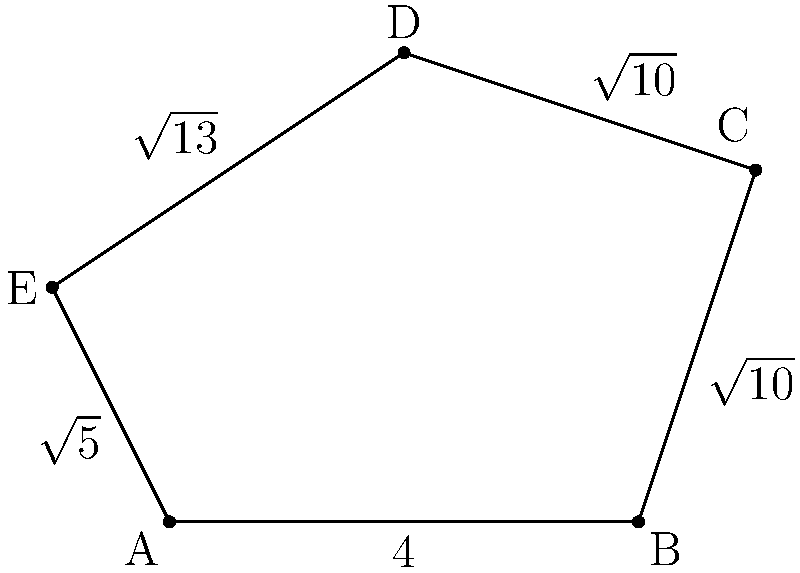As a future diplomatic translator, you might encounter geometrical descriptions in various documents. Consider the irregular pentagon ABCDE shown in the figure. Given that the coordinates of the vertices are A(0,0), B(4,0), C(5,3), D(2,4), and E(-1,2), calculate the perimeter of the pentagon. Express your answer in simplified radical form. To find the perimeter of the irregular pentagon, we need to calculate the distance between each pair of consecutive vertices and sum them up. We'll use the distance formula: $d = \sqrt{(x_2-x_1)^2 + (y_2-y_1)^2}$

1. Distance AB:
   $AB = \sqrt{(4-0)^2 + (0-0)^2} = \sqrt{16} = 4$

2. Distance BC:
   $BC = \sqrt{(5-4)^2 + (3-0)^2} = \sqrt{1 + 9} = \sqrt{10}$

3. Distance CD:
   $CD = \sqrt{(2-5)^2 + (4-3)^2} = \sqrt{9 + 1} = \sqrt{10}$

4. Distance DE:
   $DE = \sqrt{(-1-2)^2 + (2-4)^2} = \sqrt{9 + 4} = \sqrt{13}$

5. Distance EA:
   $EA = \sqrt{(0-(-1))^2 + (0-2)^2} = \sqrt{1 + 4} = \sqrt{5}$

Now, we sum up all these distances:

Perimeter = $4 + \sqrt{10} + \sqrt{10} + \sqrt{13} + \sqrt{5}$

Simplifying:
Perimeter = $4 + 2\sqrt{10} + \sqrt{13} + \sqrt{5}$

This is the simplified radical form of the perimeter.
Answer: $4 + 2\sqrt{10} + \sqrt{13} + \sqrt{5}$ 